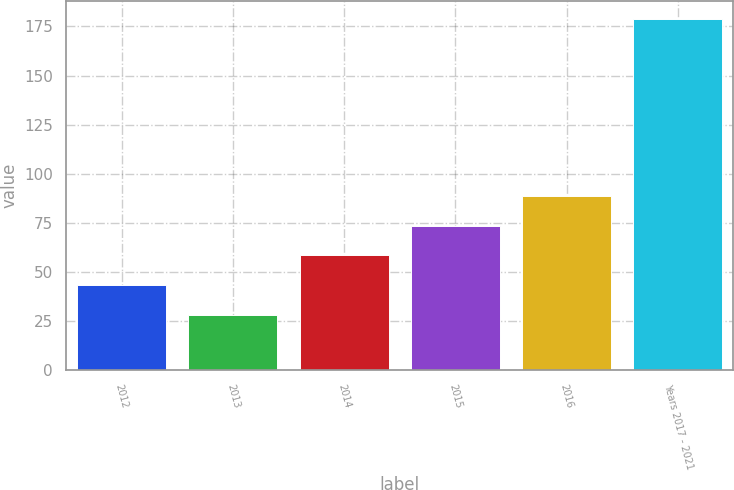Convert chart to OTSL. <chart><loc_0><loc_0><loc_500><loc_500><bar_chart><fcel>2012<fcel>2013<fcel>2014<fcel>2015<fcel>2016<fcel>Years 2017 - 2021<nl><fcel>43.1<fcel>28<fcel>58.2<fcel>73.3<fcel>88.4<fcel>179<nl></chart> 